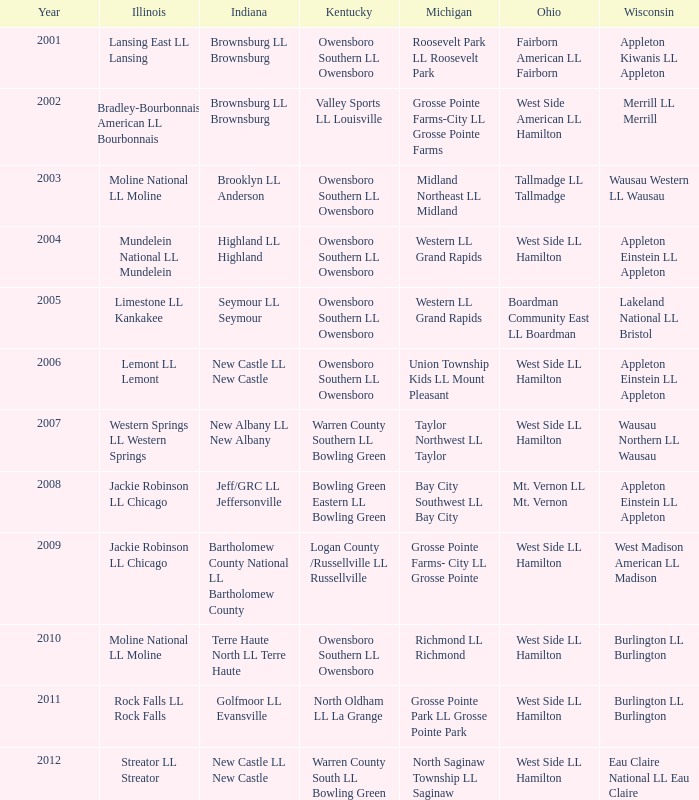When midland northeast ll midland was the little league team for michigan, what was the corresponding team in indiana? Brooklyn LL Anderson. 